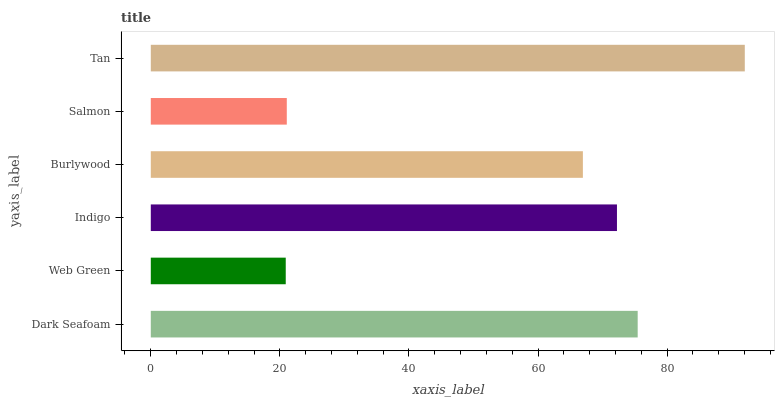Is Web Green the minimum?
Answer yes or no. Yes. Is Tan the maximum?
Answer yes or no. Yes. Is Indigo the minimum?
Answer yes or no. No. Is Indigo the maximum?
Answer yes or no. No. Is Indigo greater than Web Green?
Answer yes or no. Yes. Is Web Green less than Indigo?
Answer yes or no. Yes. Is Web Green greater than Indigo?
Answer yes or no. No. Is Indigo less than Web Green?
Answer yes or no. No. Is Indigo the high median?
Answer yes or no. Yes. Is Burlywood the low median?
Answer yes or no. Yes. Is Salmon the high median?
Answer yes or no. No. Is Dark Seafoam the low median?
Answer yes or no. No. 